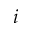Convert formula to latex. <formula><loc_0><loc_0><loc_500><loc_500>i</formula> 